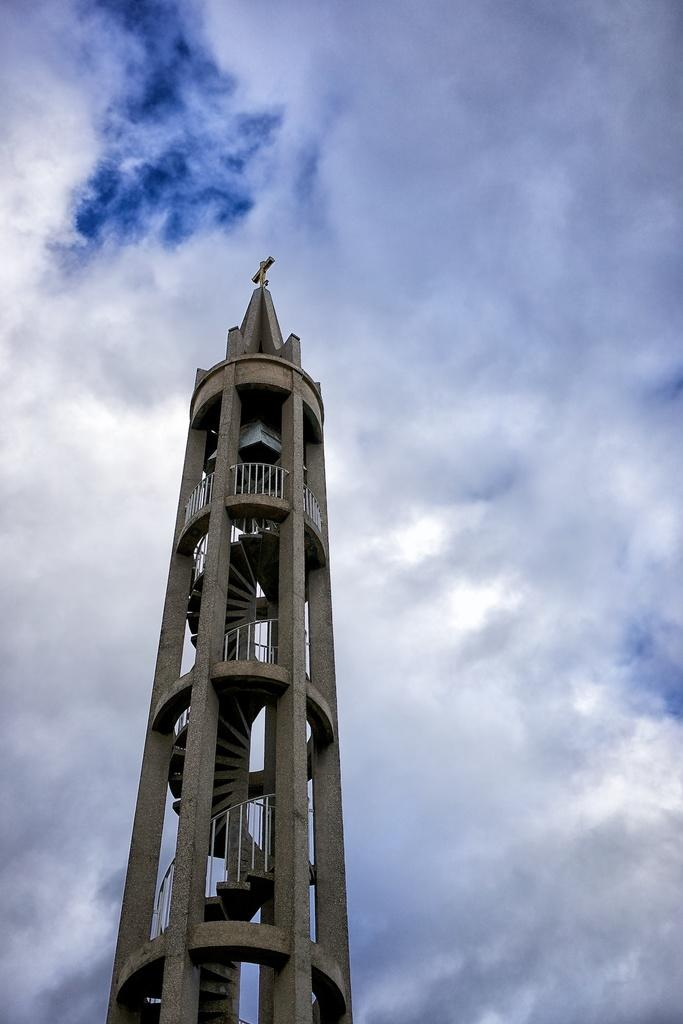What structure is the main focus of the image? There is a tower in the image. How can someone access the tower? There are stairs leading to the tower. What safety feature is present along the stairs? There is a railing associated with the stairs. What can be seen in the sky in the image? There are clouds visible in the image, and the sky is blue. What type of peace symbol can be seen on the tower in the image? There is no peace symbol present on the tower in the image. How many stamps are visible on the tower in the image? There are no stamps visible on the tower in the image. 